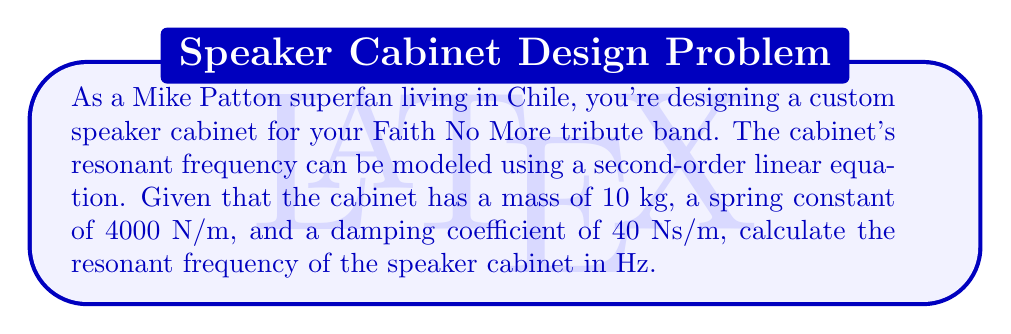Give your solution to this math problem. To calculate the resonant frequency of the speaker cabinet, we'll use the second-order linear equation that describes a damped harmonic oscillator:

$$m\frac{d^2x}{dt^2} + b\frac{dx}{dt} + kx = 0$$

Where:
$m$ = mass (kg)
$b$ = damping coefficient (Ns/m)
$k$ = spring constant (N/m)

The resonant frequency for an underdamped system is given by:

$$f_r = \frac{1}{2\pi}\sqrt{\frac{k}{m} - \frac{b^2}{4m^2}}$$

Let's substitute the given values:
$m = 10$ kg
$k = 4000$ N/m
$b = 40$ Ns/m

Now, let's calculate step by step:

1) First, calculate $\frac{k}{m}$:
   $$\frac{k}{m} = \frac{4000}{10} = 400$$

2) Then, calculate $\frac{b^2}{4m^2}$:
   $$\frac{b^2}{4m^2} = \frac{40^2}{4(10^2)} = \frac{1600}{400} = 4$$

3) Subtract these values:
   $$\frac{k}{m} - \frac{b^2}{4m^2} = 400 - 4 = 396$$

4) Take the square root:
   $$\sqrt{396} \approx 19.8997$$

5) Finally, divide by $2\pi$:
   $$f_r = \frac{19.8997}{2\pi} \approx 3.1662$$

Therefore, the resonant frequency of the speaker cabinet is approximately 3.17 Hz.
Answer: $f_r \approx 3.17$ Hz 